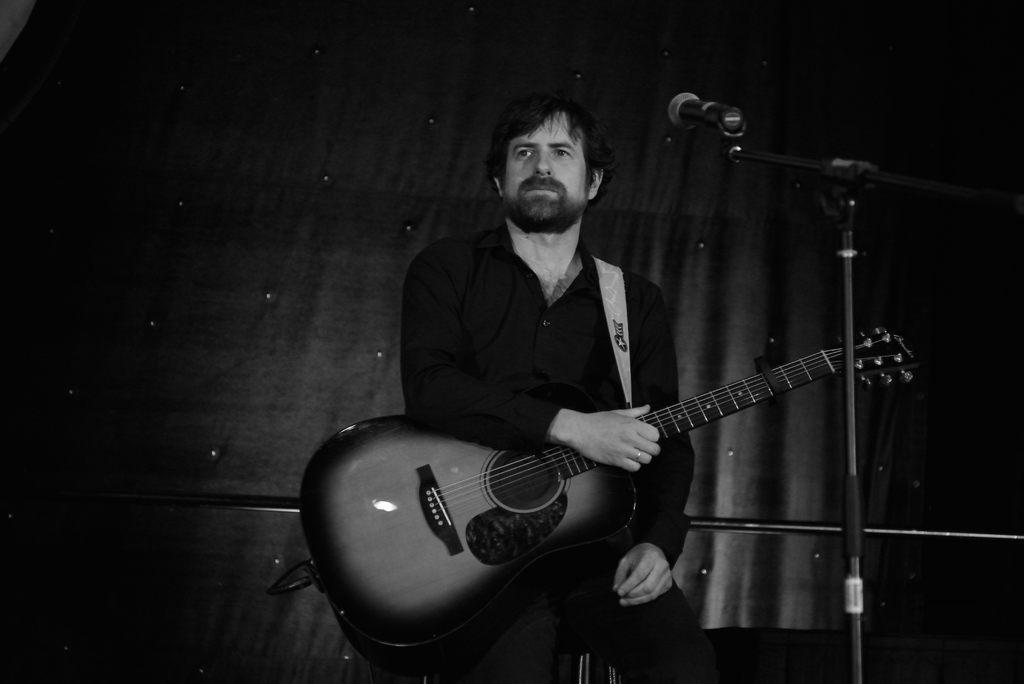Who is the person in the image? There is a man in the image. What is the man holding in the image? The man is holding a guitar. What is the man standing near in the image? The man is standing in front of a microphone. What can be seen in the background of the image? There are curtains in the background of the image. Is there a desk visible in the image? No, there is no desk present in the image. 